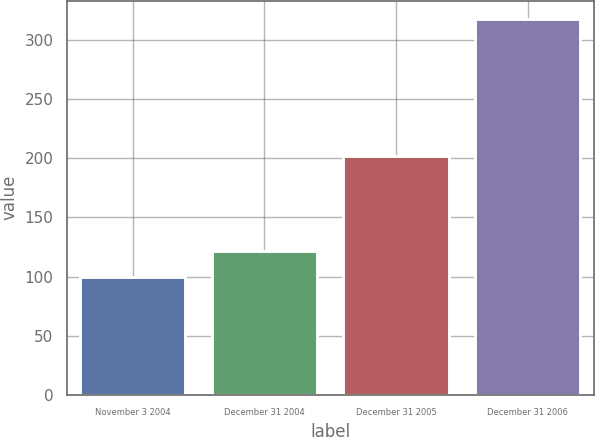Convert chart to OTSL. <chart><loc_0><loc_0><loc_500><loc_500><bar_chart><fcel>November 3 2004<fcel>December 31 2004<fcel>December 31 2005<fcel>December 31 2006<nl><fcel>100<fcel>121.75<fcel>202<fcel>317.5<nl></chart> 